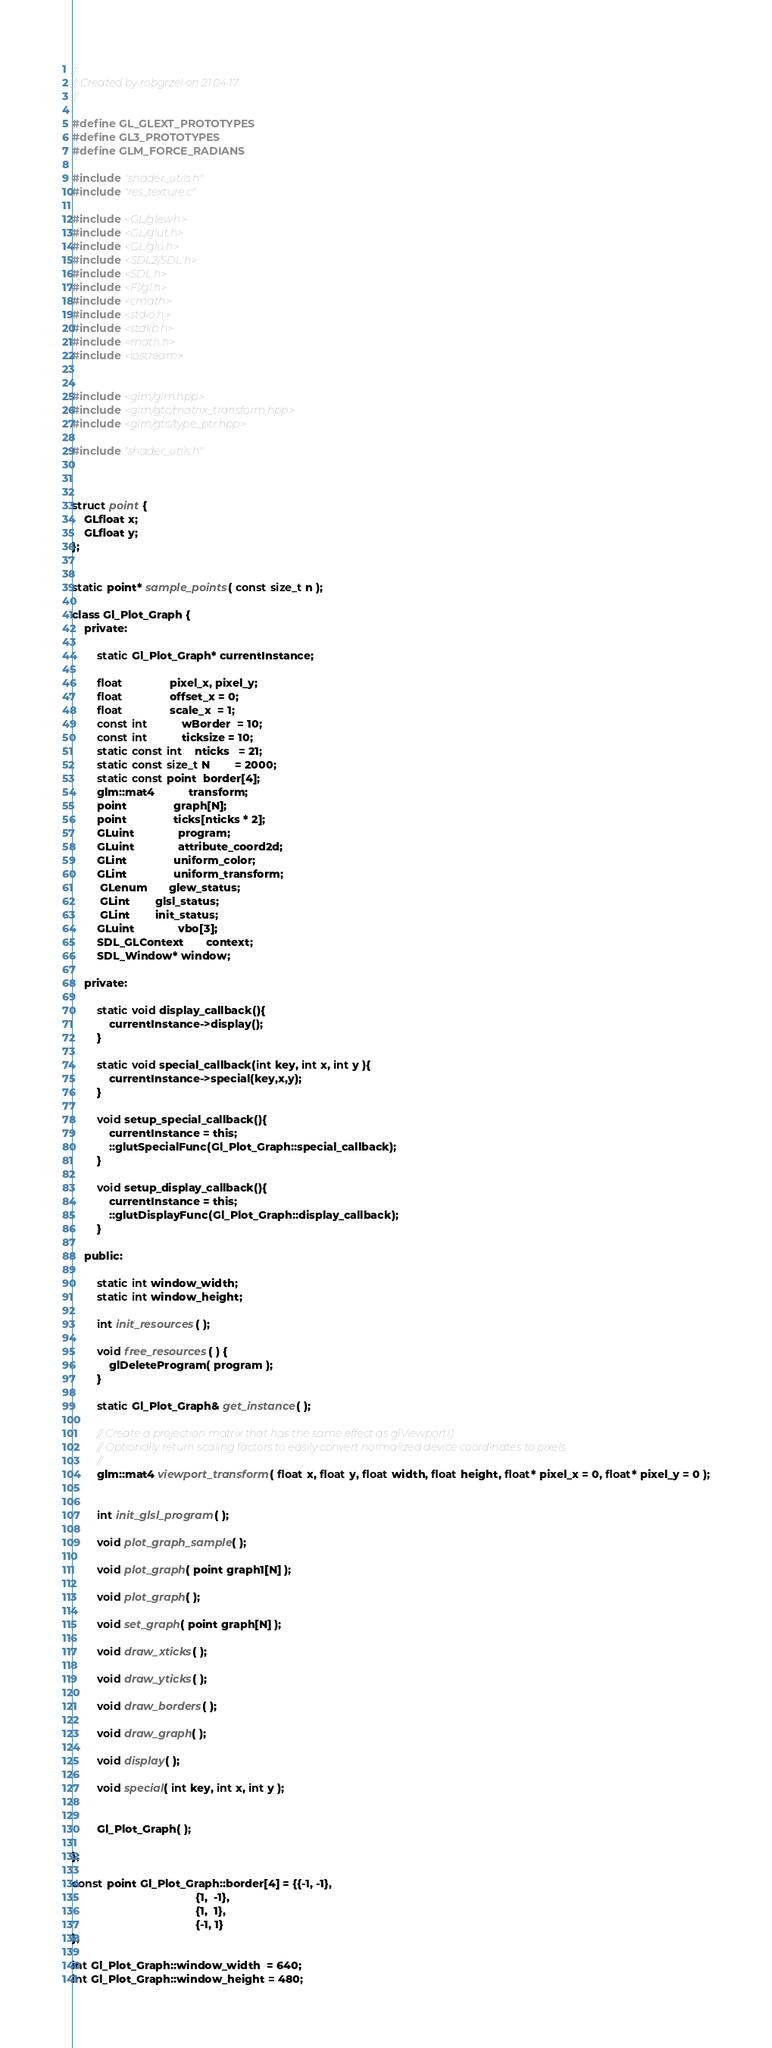<code> <loc_0><loc_0><loc_500><loc_500><_C_>//
// Created by robgrzel on 21.04.17.
//

#define GL_GLEXT_PROTOTYPES
#define GL3_PROTOTYPES
#define GLM_FORCE_RADIANS

#include "shader_utils.h"
#include "res_texture.c"

#include <GL/glew.h>
#include <GL/glut.h>
#include <GL/glu.h>
#include <SDL2/SDL.h>
#include <SDL.h>
#include <Fl/gl.h>
#include <cmath>
#include <stdio.h>
#include <stdlib.h>
#include <math.h>
#include <iostream>


#include <glm/glm.hpp>
#include <glm/gtc/matrix_transform.hpp>
#include <glm/gtc/type_ptr.hpp>

#include "shader_utils.h"



struct point {
	GLfloat x;
	GLfloat y;
};


static point* sample_points( const size_t n );

class Gl_Plot_Graph {
	private:

		static Gl_Plot_Graph* currentInstance;

		float               pixel_x, pixel_y;
		float               offset_x = 0;
		float               scale_x  = 1;
		const int           wBorder  = 10;
		const int           ticksize = 10;
		static const int    nticks   = 21;
		static const size_t N        = 2000;
		static const point  border[4];
		glm::mat4           transform;
		point               graph[N];
		point               ticks[nticks * 2];
		GLuint              program;
		GLuint              attribute_coord2d;
		GLint               uniform_color;
		GLint               uniform_transform;
		 GLenum       glew_status;
		 GLint        glsl_status;
		 GLint        init_status;
		GLuint              vbo[3];
		SDL_GLContext       context;
		SDL_Window* window;

	private:

		static void display_callback(){
			currentInstance->display();
		}

		static void special_callback(int key, int x, int y ){
			currentInstance->special(key,x,y);
		}

		void setup_special_callback(){
			currentInstance = this;
			::glutSpecialFunc(Gl_Plot_Graph::special_callback);
		}

		void setup_display_callback(){
			currentInstance = this;
			::glutDisplayFunc(Gl_Plot_Graph::display_callback);
		}

	public:

		static int window_width;
		static int window_height;

		int init_resources( );

		void free_resources( ) {
			glDeleteProgram( program );
		}

		static Gl_Plot_Graph& get_instance( );

		// Create a projection matrix that has the same effect as glViewport().
		// Optionally return scaling factors to easily convert normalized device coordinates to pixels.
		//
		glm::mat4 viewport_transform( float x, float y, float width, float height, float* pixel_x = 0, float* pixel_y = 0 );


		int init_glsl_program( );

		void plot_graph_sample( );

		void plot_graph( point graph1[N] );

		void plot_graph( );

		void set_graph( point graph[N] );

		void draw_xticks( );

		void draw_yticks( );

		void draw_borders( );

		void draw_graph( );

		void display( );

		void special( int key, int x, int y );


		Gl_Plot_Graph( );

};

const point Gl_Plot_Graph::border[4] = {{-1, -1},
                                        {1,  -1},
                                        {1,  1},
                                        {-1, 1}
};

int Gl_Plot_Graph::window_width  = 640;
int Gl_Plot_Graph::window_height = 480;


</code> 